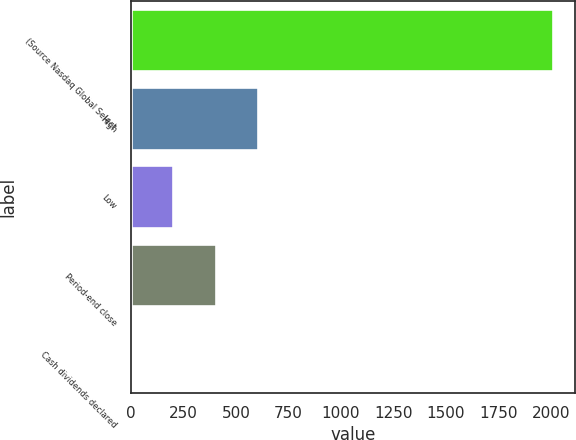<chart> <loc_0><loc_0><loc_500><loc_500><bar_chart><fcel>(Source Nasdaq Global Select<fcel>High<fcel>Low<fcel>Period-end close<fcel>Cash dividends declared<nl><fcel>2012<fcel>603.89<fcel>201.57<fcel>402.73<fcel>0.41<nl></chart> 